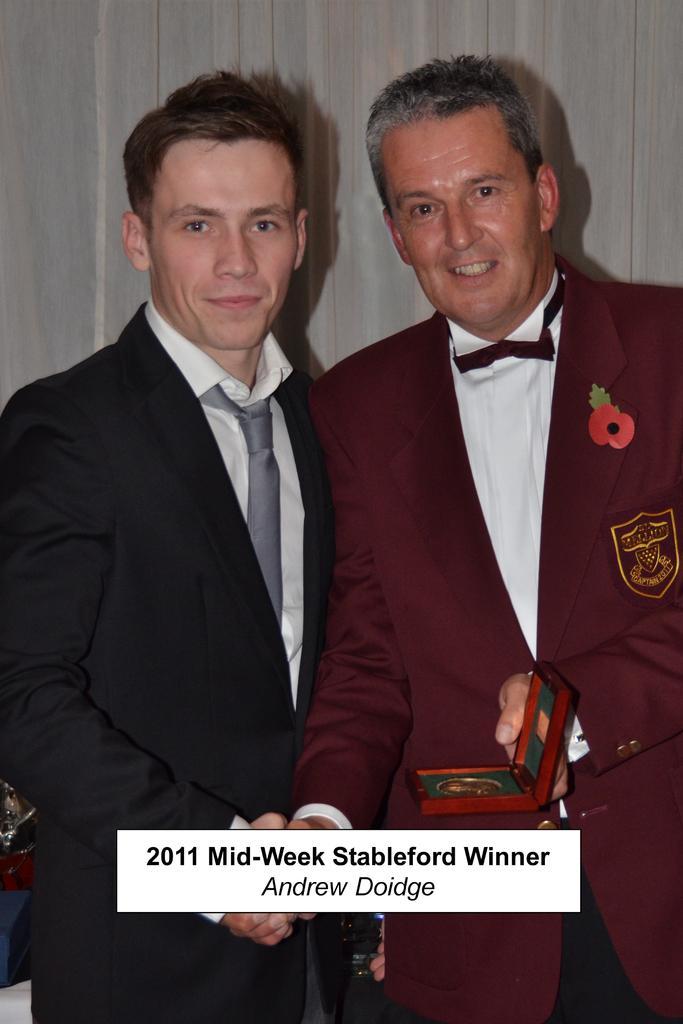Could you give a brief overview of what you see in this image? In this picture we can see two people and one person is holding an object, here we can see some text on it and we can see a wall in the background. 